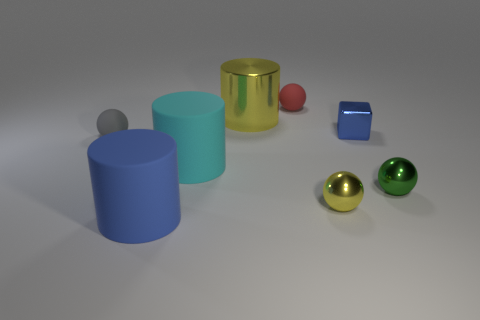There is a cyan cylinder that is the same material as the gray thing; what is its size?
Your answer should be very brief. Large. What size is the cyan thing that is on the left side of the yellow metallic object that is in front of the big matte thing behind the small green object?
Offer a terse response. Large. There is a matte sphere that is right of the blue cylinder; what is its size?
Make the answer very short. Small. What number of red things are rubber objects or big shiny objects?
Ensure brevity in your answer.  1. Is there a brown cylinder that has the same size as the cyan rubber object?
Offer a terse response. No. What is the material of the yellow ball that is the same size as the blue metal object?
Keep it short and to the point. Metal. Does the yellow thing that is to the right of the red matte thing have the same size as the ball behind the blue metallic thing?
Your response must be concise. Yes. What number of things are tiny blue things or small gray matte spheres that are to the left of the large yellow cylinder?
Your response must be concise. 2. Is there a tiny red object of the same shape as the tiny green shiny thing?
Offer a terse response. Yes. There is a yellow object that is in front of the small shiny object that is behind the gray sphere; what size is it?
Give a very brief answer. Small. 